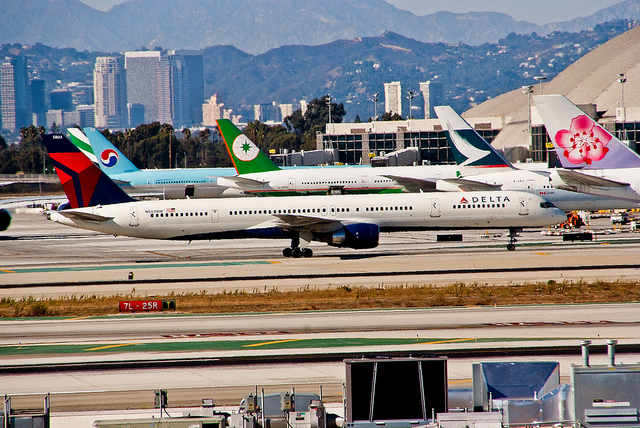Identify and read out the text in this image. TL 25R T DELTA 